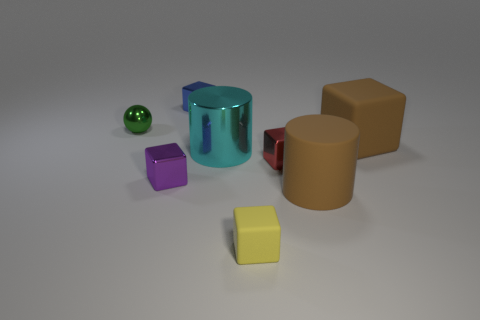Do the purple block and the red block have the same size?
Ensure brevity in your answer.  Yes. What is the material of the large cyan object?
Your answer should be compact. Metal. There is a green object that is the same size as the purple shiny cube; what is its material?
Make the answer very short. Metal. Is there another green metallic ball that has the same size as the green metal sphere?
Give a very brief answer. No. Are there the same number of brown matte cubes behind the tiny shiny ball and yellow matte cubes that are behind the tiny red shiny object?
Provide a short and direct response. Yes. Is the number of tiny blue metallic cubes greater than the number of matte cubes?
Provide a short and direct response. No. What number of metal objects are cylinders or blocks?
Make the answer very short. 4. What number of things have the same color as the matte cylinder?
Give a very brief answer. 1. There is a large brown thing that is on the right side of the big brown matte thing that is in front of the brown object that is behind the large matte cylinder; what is it made of?
Your answer should be compact. Rubber. What is the color of the cylinder that is left of the rubber block on the left side of the tiny red metal object?
Your answer should be very brief. Cyan. 